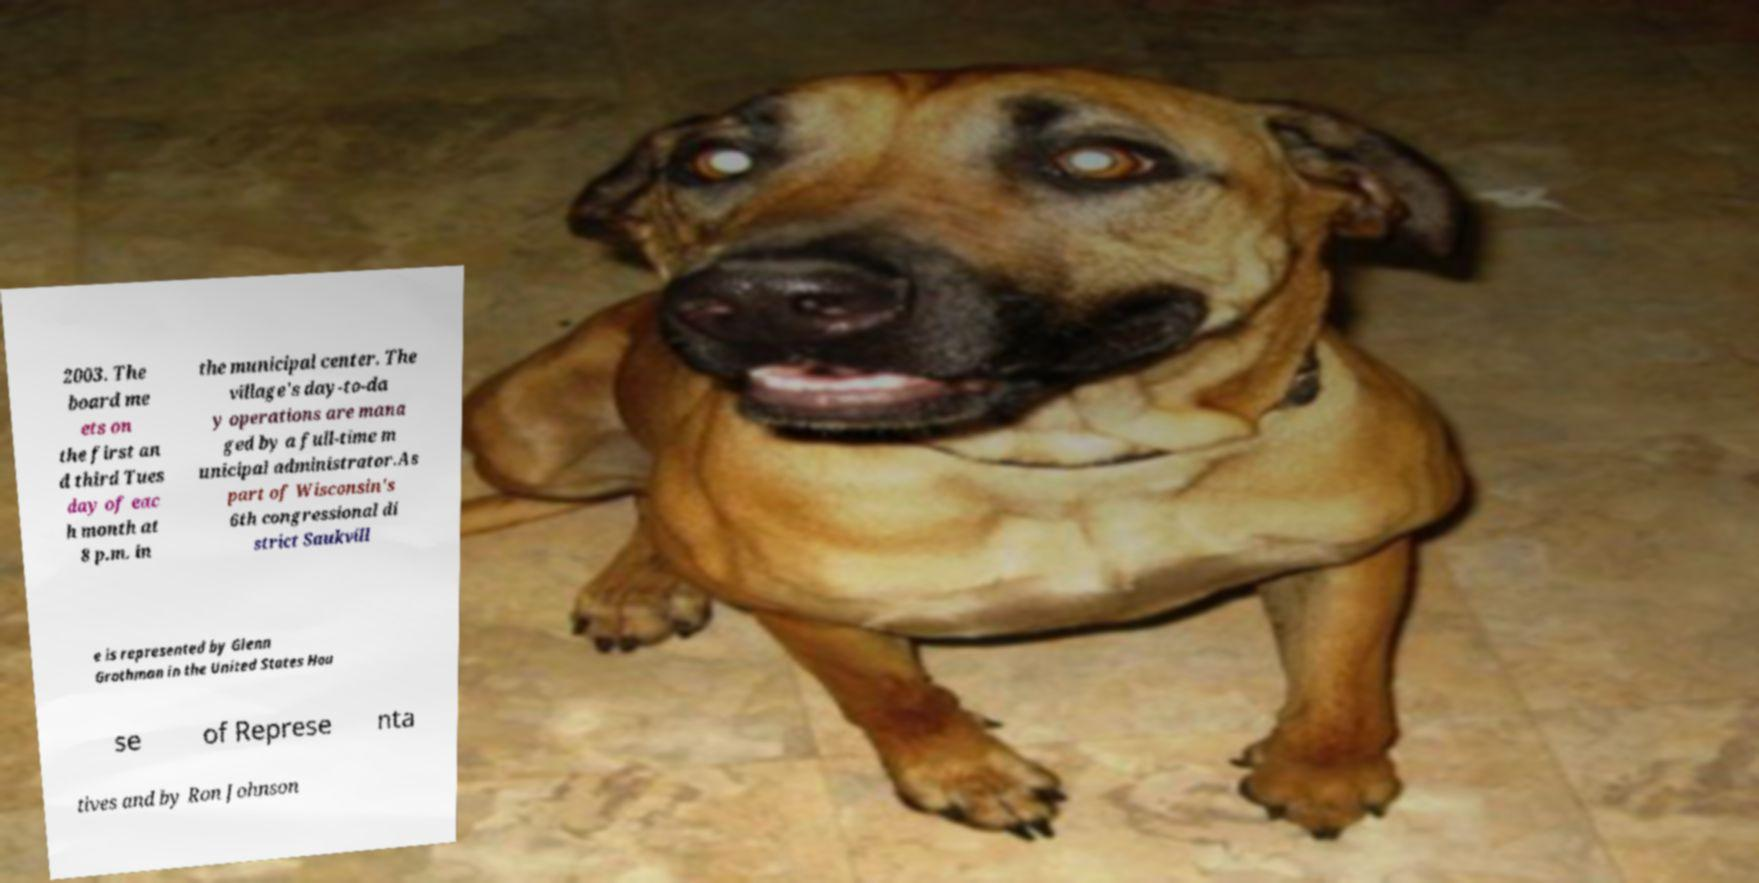I need the written content from this picture converted into text. Can you do that? 2003. The board me ets on the first an d third Tues day of eac h month at 8 p.m. in the municipal center. The village's day-to-da y operations are mana ged by a full-time m unicipal administrator.As part of Wisconsin's 6th congressional di strict Saukvill e is represented by Glenn Grothman in the United States Hou se of Represe nta tives and by Ron Johnson 